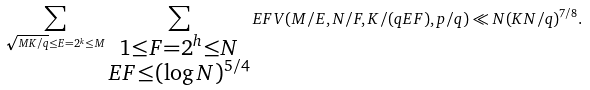Convert formula to latex. <formula><loc_0><loc_0><loc_500><loc_500>\sum _ { \sqrt { M K / q } \leq E = 2 ^ { k } \leq M } \sum _ { \substack { 1 \leq F = 2 ^ { h } \leq N \\ E F \leq ( \log N ) ^ { 5 / 4 } } } E F V ( M / E , N / F , K / ( q E F ) , p / q ) \ll N ( K N / q ) ^ { 7 / 8 } .</formula> 